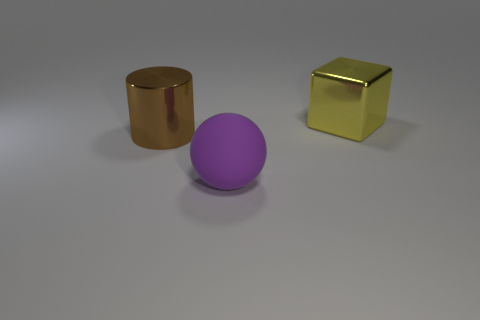How many other things are there of the same size as the purple thing?
Make the answer very short. 2. What number of spheres are either purple matte things or blue objects?
Ensure brevity in your answer.  1. Is there anything else that is made of the same material as the large sphere?
Provide a short and direct response. No. There is a large object in front of the metal thing in front of the large thing that is to the right of the purple ball; what is it made of?
Provide a short and direct response. Rubber. How many brown things have the same material as the yellow thing?
Keep it short and to the point. 1. Is the size of the metallic thing on the left side of the cube the same as the yellow shiny cube?
Make the answer very short. Yes. There is a cylinder that is made of the same material as the yellow thing; what color is it?
Your response must be concise. Brown. There is a cube; how many spheres are left of it?
Offer a very short reply. 1. Do the big shiny object on the left side of the big yellow cube and the metallic thing right of the purple rubber thing have the same color?
Your response must be concise. No. Do the big thing that is on the right side of the large purple rubber ball and the object that is left of the large matte thing have the same shape?
Your answer should be compact. No. 